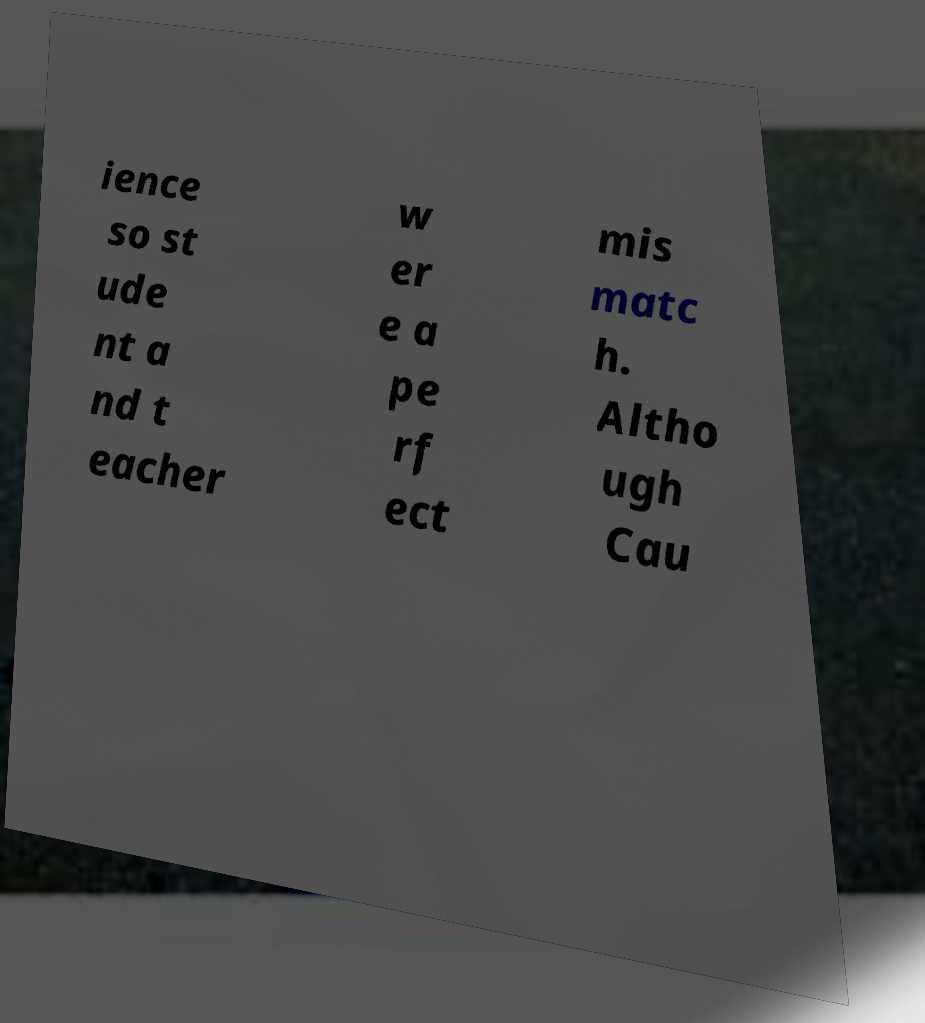What messages or text are displayed in this image? I need them in a readable, typed format. ience so st ude nt a nd t eacher w er e a pe rf ect mis matc h. Altho ugh Cau 